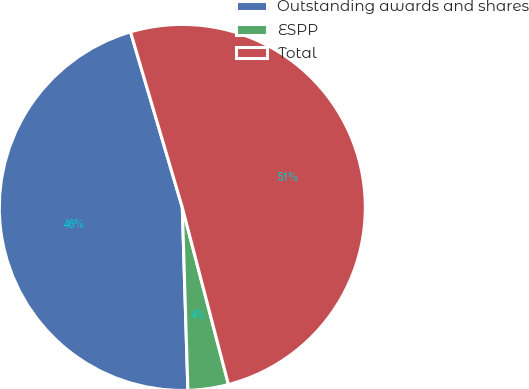<chart> <loc_0><loc_0><loc_500><loc_500><pie_chart><fcel>Outstanding awards and shares<fcel>ESPP<fcel>Total<nl><fcel>45.92%<fcel>3.57%<fcel>50.51%<nl></chart> 